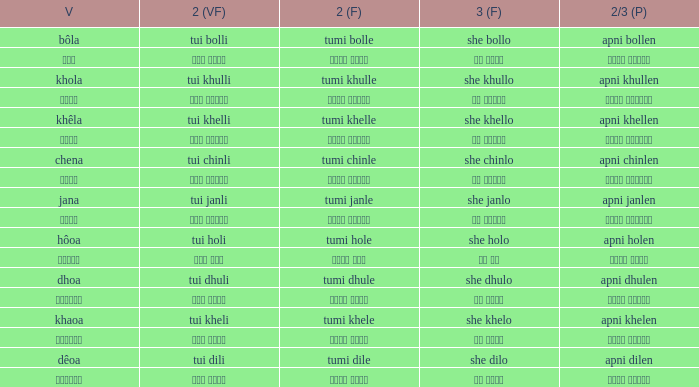What is the 2nd verb for chena? Tumi chinle. 